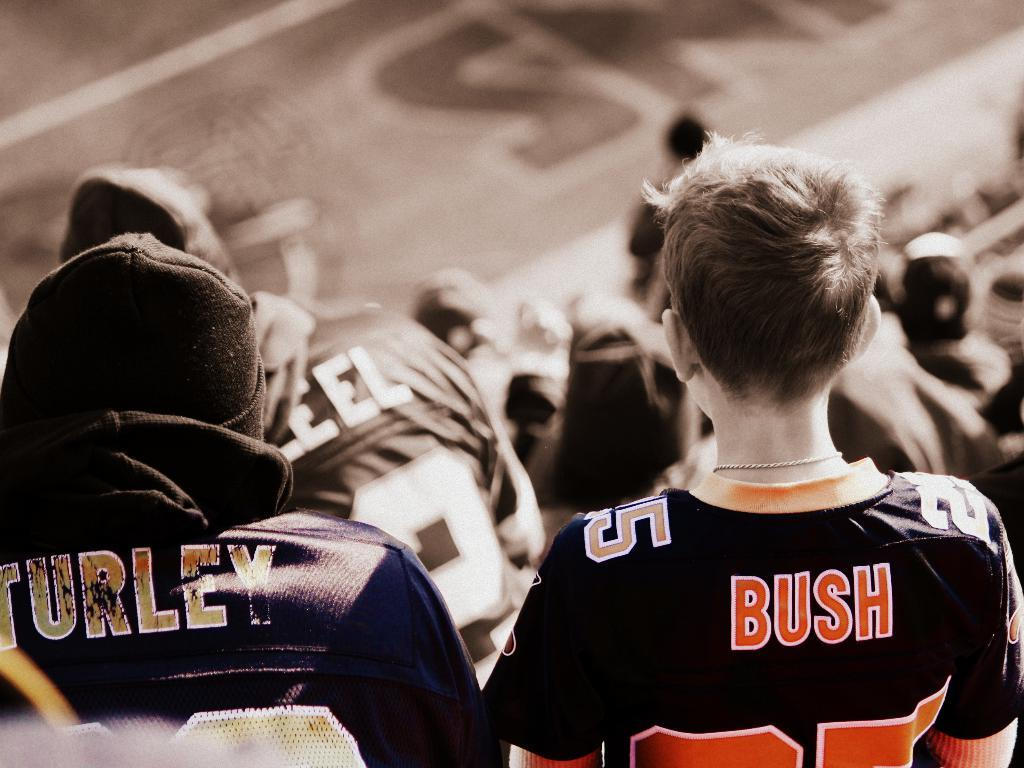<image>
Share a concise interpretation of the image provided. Boy wearing a BUSH jersey is sitting next to someone wearing a TURLEY jersey. 